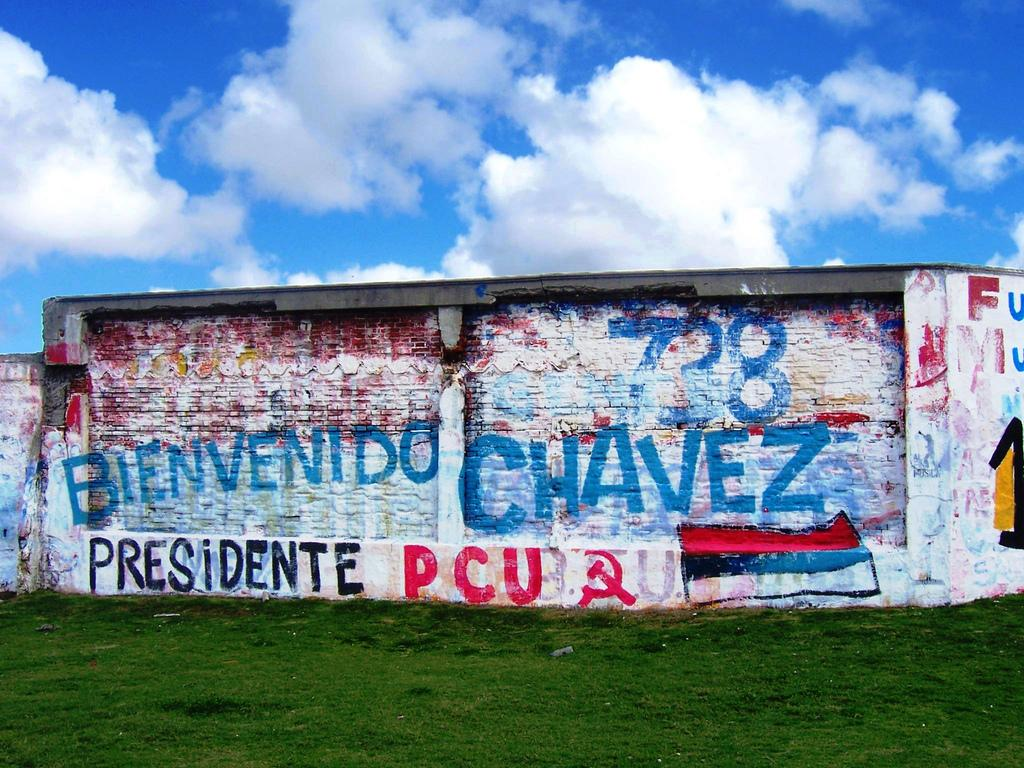What type of vegetation can be seen in the image? There is grass in the image. What is on the wall in the image? There is a painting and text on the wall. What can be seen in the background of the image? The sky is visible in the background of the image. What is the condition of the sky in the image? Clouds are present in the sky. Where is the jar located in the image? There is no jar present in the image. What type of food is being served in the lunchroom in the image? There is no lunchroom present in the image. 